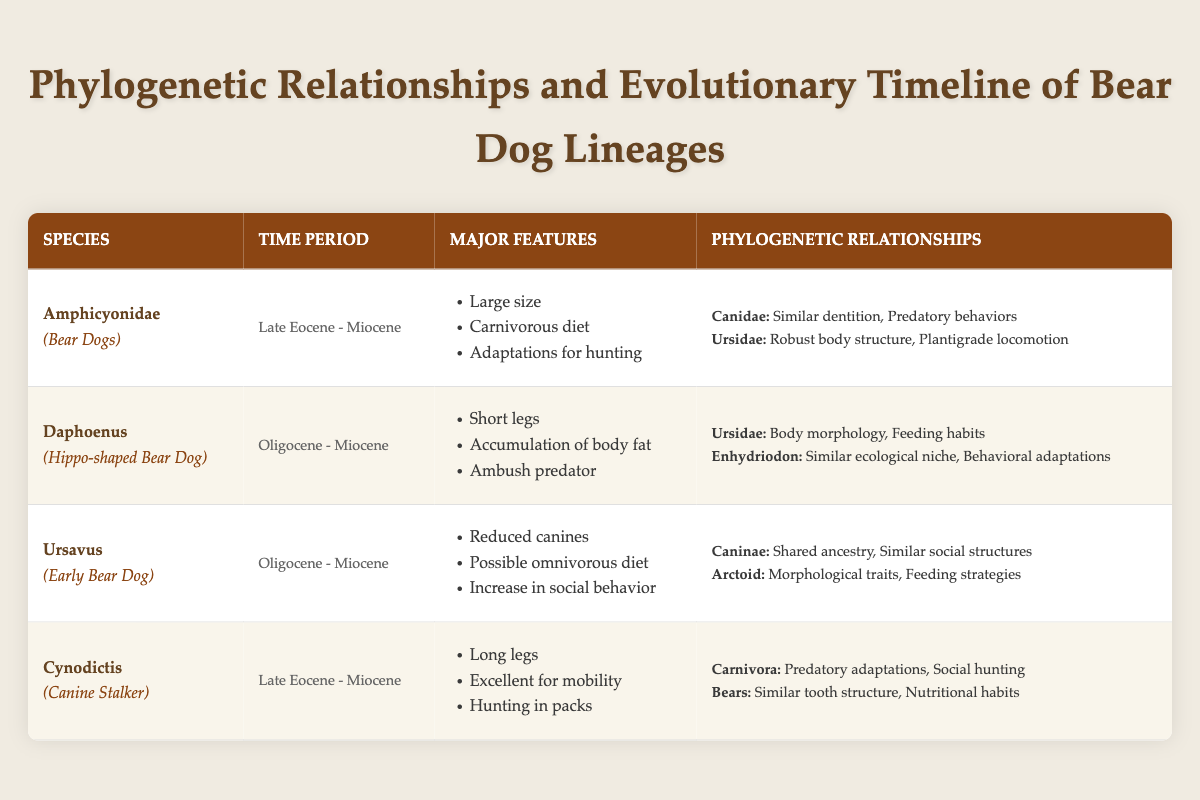What is the time period for the species Amphicyonidae? The table lists Amphicyonidae with a time period from "Late Eocene" to "Miocene."
Answer: Late Eocene - Miocene Which bear dog lineage has features like short legs and accumulation of body fat? The table details that Daphoenus has features such as short legs and accumulation of body fat.
Answer: Daphoenus How many bear dog lineages listed were present during the Oligocene? Two species, Daphoenus and Ursavus, are both noted to be from the Oligocene to Miocene time period. Therefore, the count is 2.
Answer: 2 Does Cynodictis have similarities with Carnivora in terms of social hunting? Yes, the table states that Cynodictis shares predatory adaptations and social hunting with Carnivora.
Answer: Yes What are the major features of Ursavus? The table describes Ursavus' major features as reduced canines, possible omnivorous diet, and an increase in social behavior.
Answer: Reduced canines, possible omnivorous diet, increase in social behavior Which bear dog lineage shares the most similarities with bears and what are these similarities? Cynodictis shares similarities with bears, including similar tooth structure and nutritional habits.
Answer: Cynodictis; similar tooth structure, nutritional habits What is the difference in time periods between the earliest and latest bear dog lineages listed? The earliest lineage is Amphicyonidae (Late Eocene) and the latest is Daphoenus (Oligocene). The difference spans from the Late Eocene to the Miocene, so it covers several geological epochs beyond just years. Specifically, it suggests they overlap, but time periods do not differ precisely in years.
Answer: They overlap in time; no strict difference Which lineage exhibited adaptations for hunting that could be broadly classified under both Canidae and Ursidae? Amphicyonidae exhibits adaptations for hunting while exhibiting relationships with both Canidae (similar dentition, predatory behaviors) and Ursidae (robust body structure, plantigrade locomotion).
Answer: Amphicyonidae 